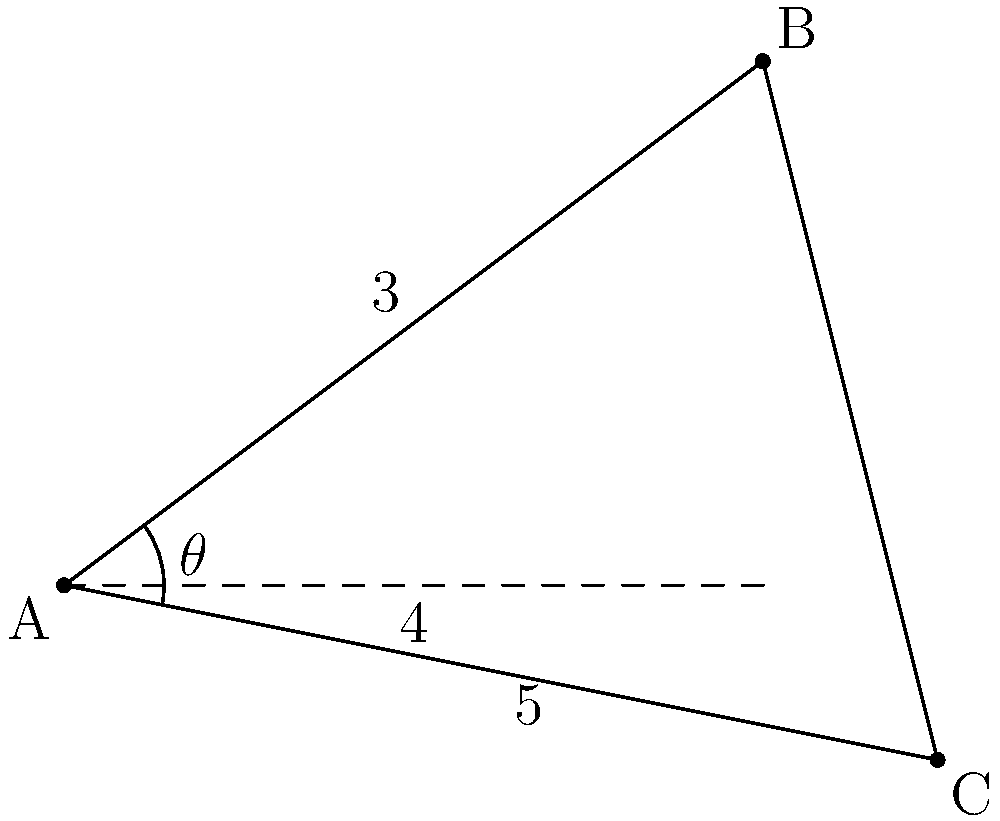In a maze-like game level, you start at point A and have two paths diverging: one leading to point B and another to point C. The path to B is 5 units long, while the path to C is 3 units long. If the horizontal distance between the two paths is 4 units, what is the angle $\theta$ between these two paths? To find the angle $\theta$ between the two paths, we can use the law of cosines. Here's how:

1) We have a triangle ABC where:
   - AB = 5 units
   - AC = 3 units
   - BC is unknown

2) The horizontal distance between B and C is 4 units, which forms a right triangle with AC.

3) Using the Pythagorean theorem in this right triangle:
   $BC^2 = 4^2 + 1^2 = 17$
   $BC = \sqrt{17}$

4) Now we can use the law of cosines:
   $\cos \theta = \frac{AB^2 + AC^2 - BC^2}{2(AB)(AC)}$

5) Substituting our values:
   $\cos \theta = \frac{5^2 + 3^2 - 17}{2(5)(3)}$

6) Simplifying:
   $\cos \theta = \frac{25 + 9 - 17}{30} = \frac{17}{30}$

7) To find $\theta$, we take the inverse cosine (arccos) of both sides:
   $\theta = \arccos(\frac{17}{30})$

8) Using a calculator or computer, we get:
   $\theta \approx 55.15°$
Answer: $55.15°$ 